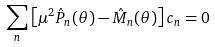<formula> <loc_0><loc_0><loc_500><loc_500>\sum _ { n } \left [ \mu ^ { 2 } \hat { P } _ { n } ( \theta ) - \hat { M } _ { n } ( \theta ) \right ] c _ { n } = 0</formula> 